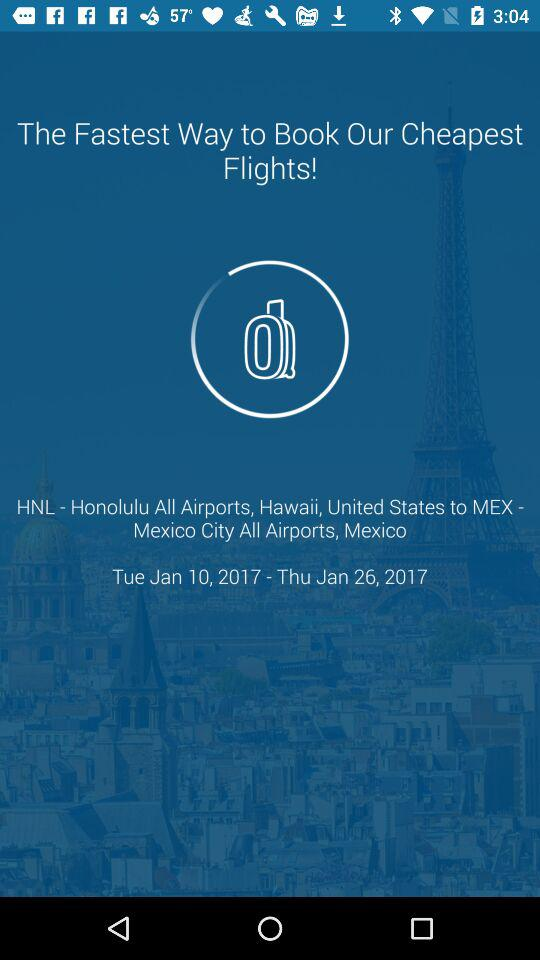Which airport is the destination?
Answer the question using a single word or phrase. MEX - Mexico City All Airports, Mexico 